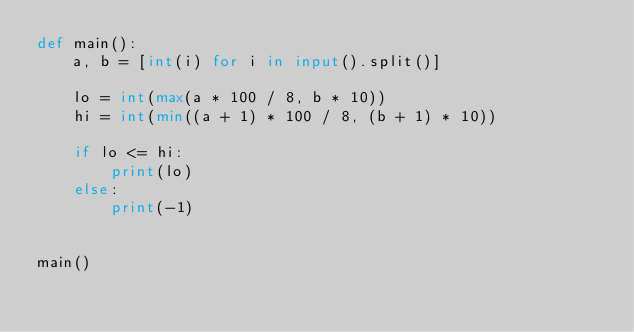<code> <loc_0><loc_0><loc_500><loc_500><_Python_>def main():
    a, b = [int(i) for i in input().split()]

    lo = int(max(a * 100 / 8, b * 10))
    hi = int(min((a + 1) * 100 / 8, (b + 1) * 10))

    if lo <= hi:
        print(lo)
    else:
        print(-1)


main()
</code> 